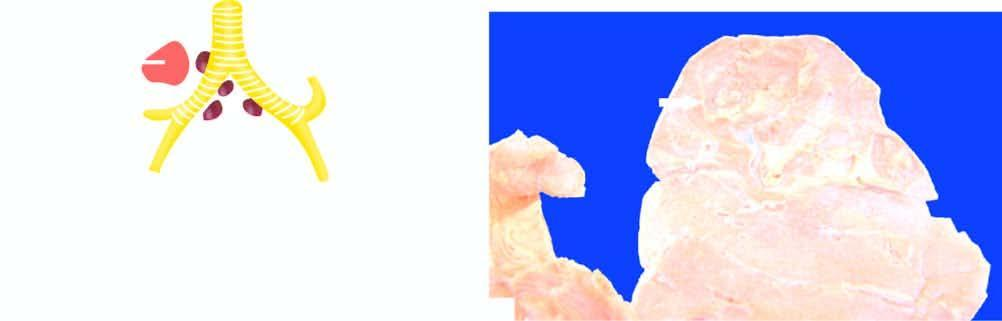where is cavitary/open fibrocaseous tuberculos?
Answer the question using a single word or phrase. Right 